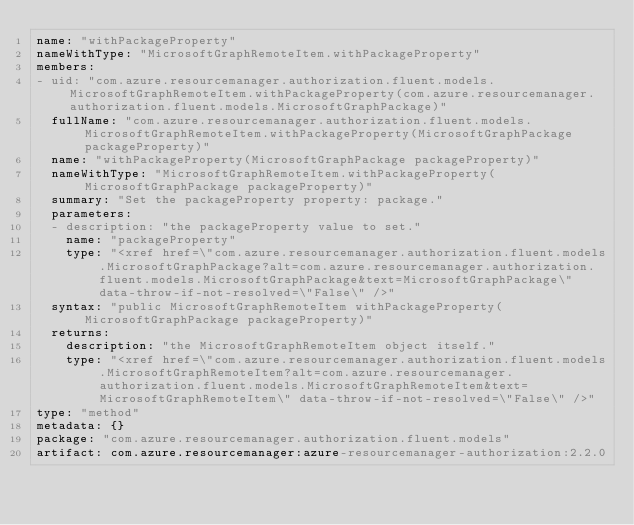Convert code to text. <code><loc_0><loc_0><loc_500><loc_500><_YAML_>name: "withPackageProperty"
nameWithType: "MicrosoftGraphRemoteItem.withPackageProperty"
members:
- uid: "com.azure.resourcemanager.authorization.fluent.models.MicrosoftGraphRemoteItem.withPackageProperty(com.azure.resourcemanager.authorization.fluent.models.MicrosoftGraphPackage)"
  fullName: "com.azure.resourcemanager.authorization.fluent.models.MicrosoftGraphRemoteItem.withPackageProperty(MicrosoftGraphPackage packageProperty)"
  name: "withPackageProperty(MicrosoftGraphPackage packageProperty)"
  nameWithType: "MicrosoftGraphRemoteItem.withPackageProperty(MicrosoftGraphPackage packageProperty)"
  summary: "Set the packageProperty property: package."
  parameters:
  - description: "the packageProperty value to set."
    name: "packageProperty"
    type: "<xref href=\"com.azure.resourcemanager.authorization.fluent.models.MicrosoftGraphPackage?alt=com.azure.resourcemanager.authorization.fluent.models.MicrosoftGraphPackage&text=MicrosoftGraphPackage\" data-throw-if-not-resolved=\"False\" />"
  syntax: "public MicrosoftGraphRemoteItem withPackageProperty(MicrosoftGraphPackage packageProperty)"
  returns:
    description: "the MicrosoftGraphRemoteItem object itself."
    type: "<xref href=\"com.azure.resourcemanager.authorization.fluent.models.MicrosoftGraphRemoteItem?alt=com.azure.resourcemanager.authorization.fluent.models.MicrosoftGraphRemoteItem&text=MicrosoftGraphRemoteItem\" data-throw-if-not-resolved=\"False\" />"
type: "method"
metadata: {}
package: "com.azure.resourcemanager.authorization.fluent.models"
artifact: com.azure.resourcemanager:azure-resourcemanager-authorization:2.2.0
</code> 